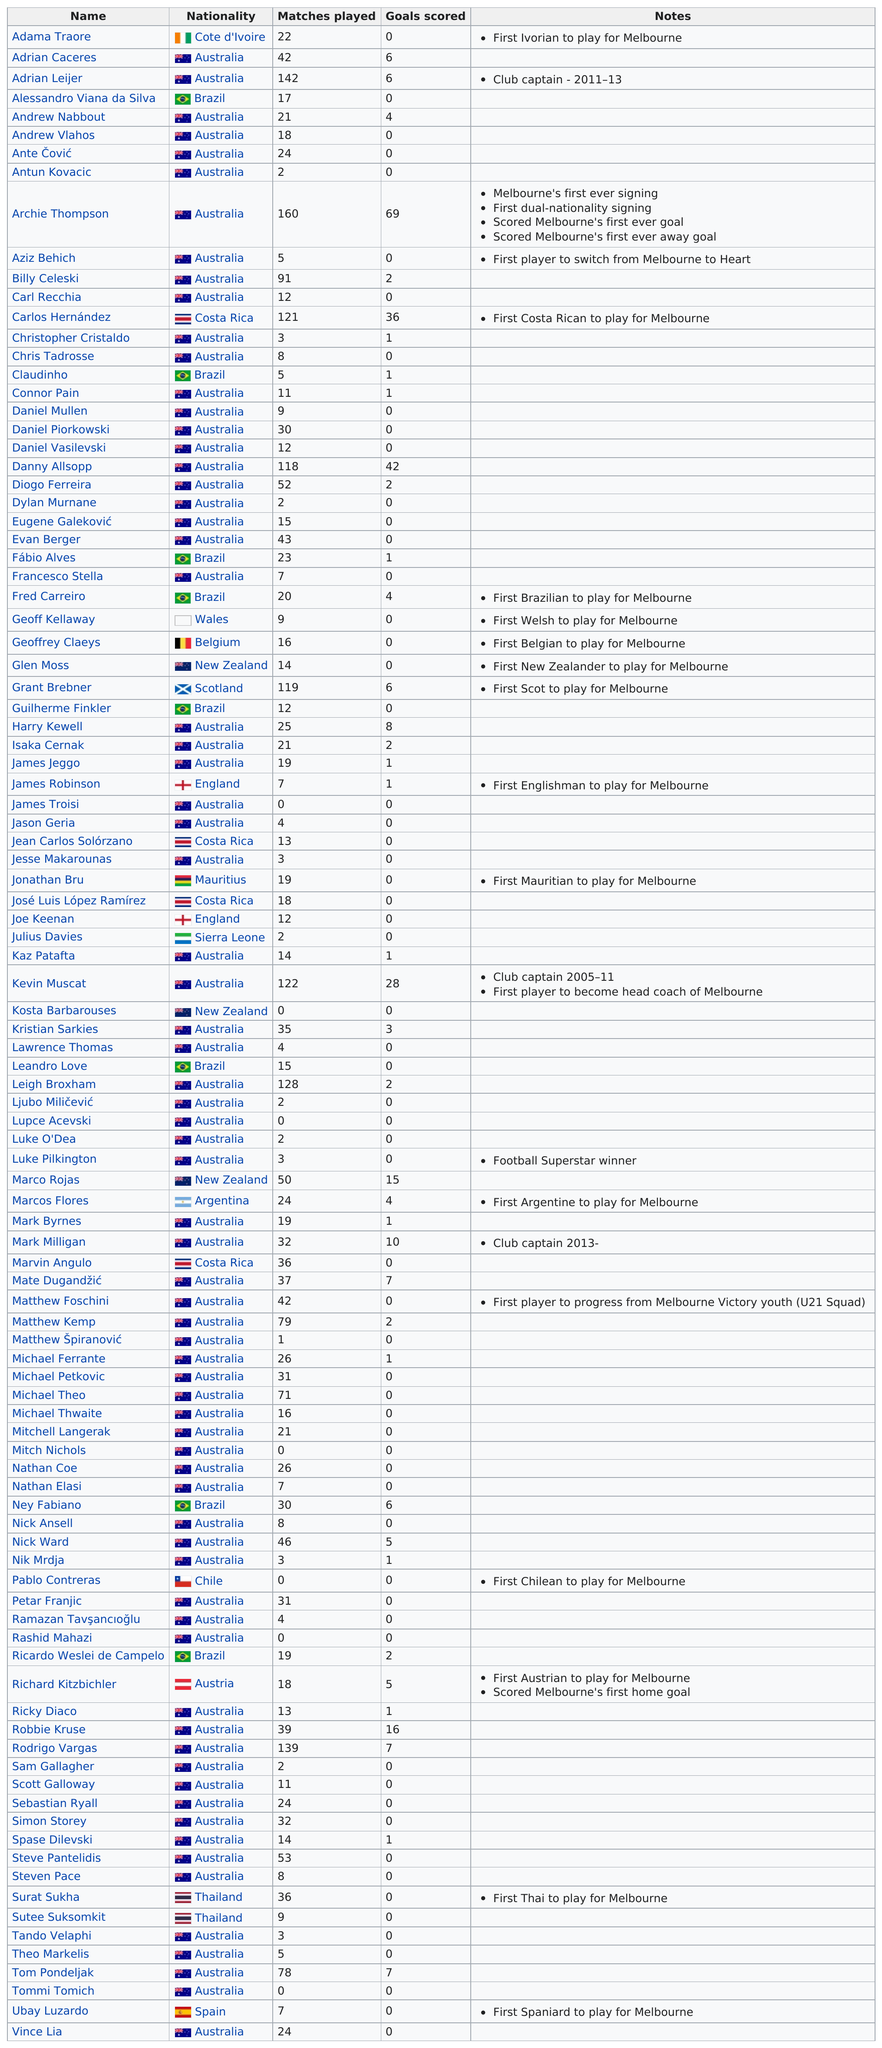Mention a couple of crucial points in this snapshot. After Australia, Brazil has the highest number of players for Melbourne. James Robinson, an English cricketer, played for Melbourne Cricket Club before any other Englishman. Archie Thompson played the most amount of matches out of all players. Archie Thompson scored more goals than Billy Celeski by 67 goals. Adama Traoré was the first Ivorian to play for the Melbourne soccer club. This historical achievement was made by Adama Traoré, who is known for his exceptional skills and outstanding performance on the field. 